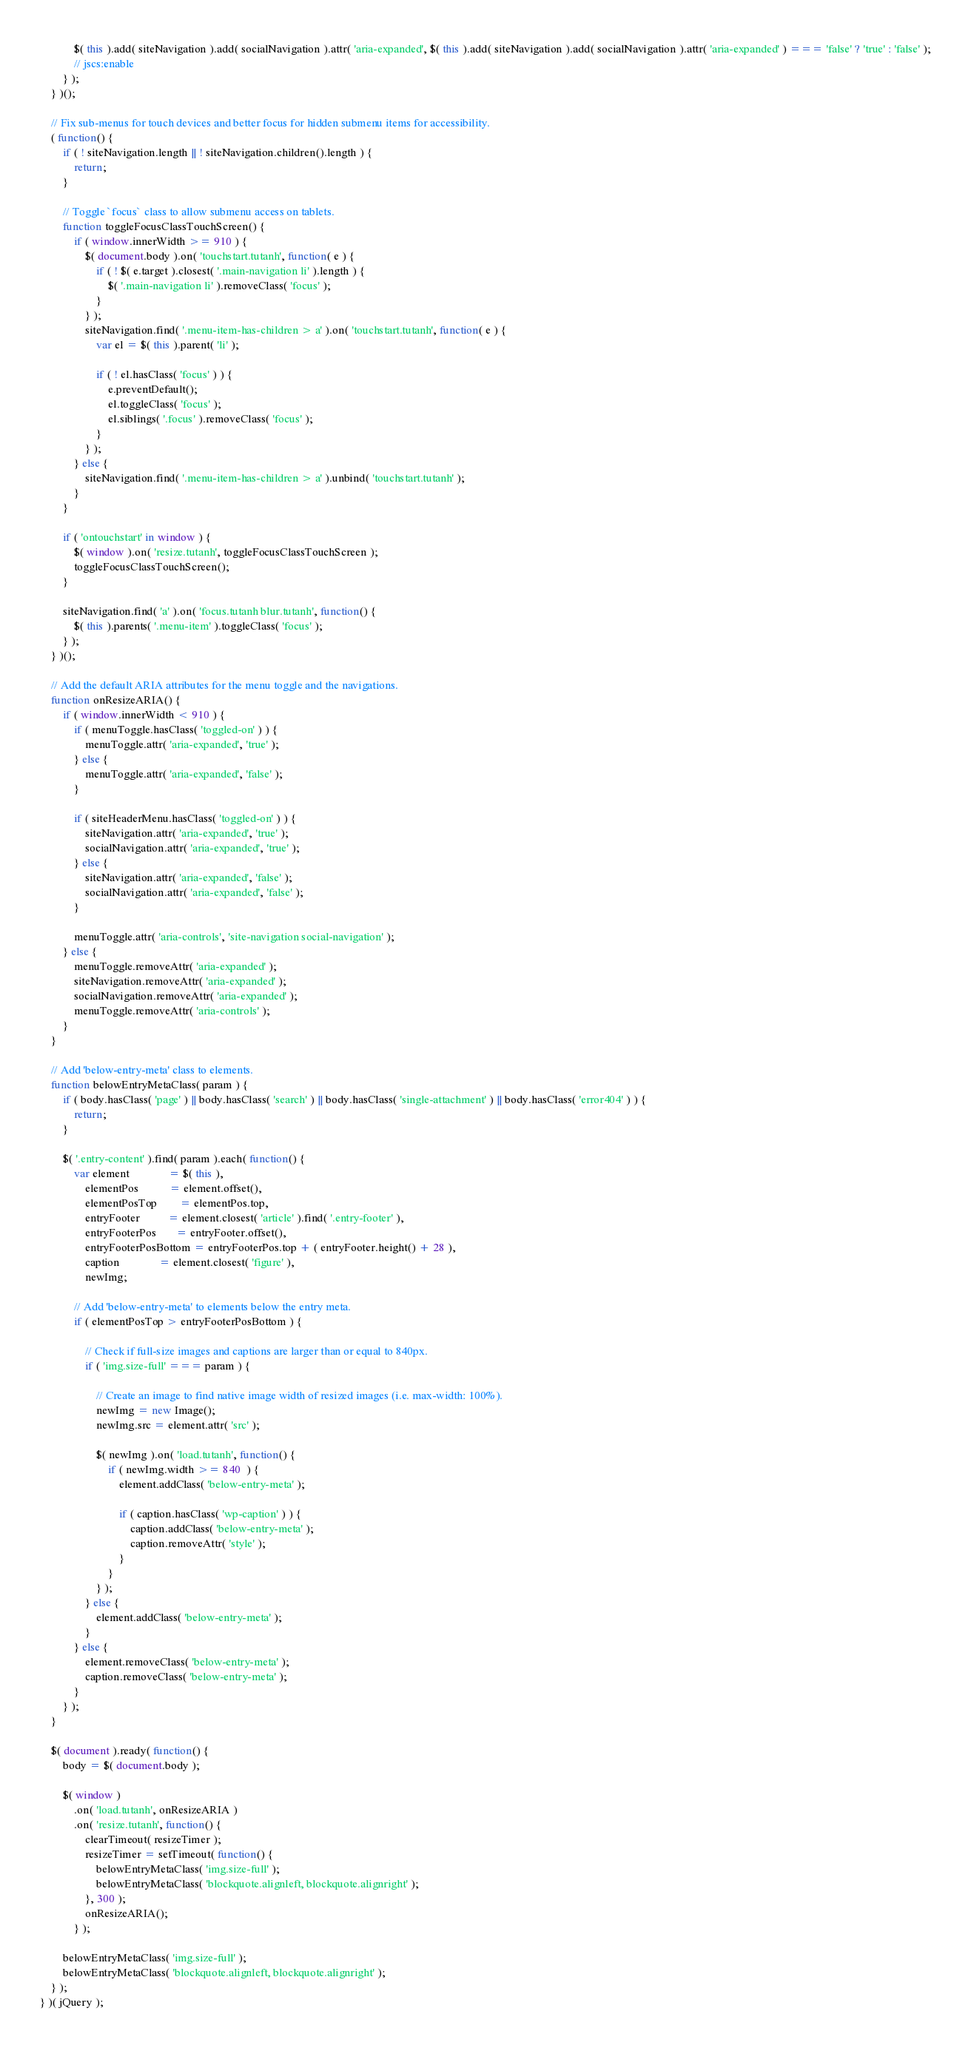Convert code to text. <code><loc_0><loc_0><loc_500><loc_500><_JavaScript_>			$( this ).add( siteNavigation ).add( socialNavigation ).attr( 'aria-expanded', $( this ).add( siteNavigation ).add( socialNavigation ).attr( 'aria-expanded' ) === 'false' ? 'true' : 'false' );
			// jscs:enable
		} );
	} )();

	// Fix sub-menus for touch devices and better focus for hidden submenu items for accessibility.
	( function() {
		if ( ! siteNavigation.length || ! siteNavigation.children().length ) {
			return;
		}

		// Toggle `focus` class to allow submenu access on tablets.
		function toggleFocusClassTouchScreen() {
			if ( window.innerWidth >= 910 ) {
				$( document.body ).on( 'touchstart.tutanh', function( e ) {
					if ( ! $( e.target ).closest( '.main-navigation li' ).length ) {
						$( '.main-navigation li' ).removeClass( 'focus' );
					}
				} );
				siteNavigation.find( '.menu-item-has-children > a' ).on( 'touchstart.tutanh', function( e ) {
					var el = $( this ).parent( 'li' );

					if ( ! el.hasClass( 'focus' ) ) {
						e.preventDefault();
						el.toggleClass( 'focus' );
						el.siblings( '.focus' ).removeClass( 'focus' );
					}
				} );
			} else {
				siteNavigation.find( '.menu-item-has-children > a' ).unbind( 'touchstart.tutanh' );
			}
		}

		if ( 'ontouchstart' in window ) {
			$( window ).on( 'resize.tutanh', toggleFocusClassTouchScreen );
			toggleFocusClassTouchScreen();
		}

		siteNavigation.find( 'a' ).on( 'focus.tutanh blur.tutanh', function() {
			$( this ).parents( '.menu-item' ).toggleClass( 'focus' );
		} );
	} )();

	// Add the default ARIA attributes for the menu toggle and the navigations.
	function onResizeARIA() {
		if ( window.innerWidth < 910 ) {
			if ( menuToggle.hasClass( 'toggled-on' ) ) {
				menuToggle.attr( 'aria-expanded', 'true' );
			} else {
				menuToggle.attr( 'aria-expanded', 'false' );
			}

			if ( siteHeaderMenu.hasClass( 'toggled-on' ) ) {
				siteNavigation.attr( 'aria-expanded', 'true' );
				socialNavigation.attr( 'aria-expanded', 'true' );
			} else {
				siteNavigation.attr( 'aria-expanded', 'false' );
				socialNavigation.attr( 'aria-expanded', 'false' );
			}

			menuToggle.attr( 'aria-controls', 'site-navigation social-navigation' );
		} else {
			menuToggle.removeAttr( 'aria-expanded' );
			siteNavigation.removeAttr( 'aria-expanded' );
			socialNavigation.removeAttr( 'aria-expanded' );
			menuToggle.removeAttr( 'aria-controls' );
		}
	}

	// Add 'below-entry-meta' class to elements.
	function belowEntryMetaClass( param ) {
		if ( body.hasClass( 'page' ) || body.hasClass( 'search' ) || body.hasClass( 'single-attachment' ) || body.hasClass( 'error404' ) ) {
			return;
		}

		$( '.entry-content' ).find( param ).each( function() {
			var element              = $( this ),
				elementPos           = element.offset(),
				elementPosTop        = elementPos.top,
				entryFooter          = element.closest( 'article' ).find( '.entry-footer' ),
				entryFooterPos       = entryFooter.offset(),
				entryFooterPosBottom = entryFooterPos.top + ( entryFooter.height() + 28 ),
				caption              = element.closest( 'figure' ),
				newImg;

			// Add 'below-entry-meta' to elements below the entry meta.
			if ( elementPosTop > entryFooterPosBottom ) {

				// Check if full-size images and captions are larger than or equal to 840px.
				if ( 'img.size-full' === param ) {

					// Create an image to find native image width of resized images (i.e. max-width: 100%).
					newImg = new Image();
					newImg.src = element.attr( 'src' );

					$( newImg ).on( 'load.tutanh', function() {
						if ( newImg.width >= 840  ) {
							element.addClass( 'below-entry-meta' );

							if ( caption.hasClass( 'wp-caption' ) ) {
								caption.addClass( 'below-entry-meta' );
								caption.removeAttr( 'style' );
							}
						}
					} );
				} else {
					element.addClass( 'below-entry-meta' );
				}
			} else {
				element.removeClass( 'below-entry-meta' );
				caption.removeClass( 'below-entry-meta' );
			}
		} );
	}

	$( document ).ready( function() {
		body = $( document.body );

		$( window )
			.on( 'load.tutanh', onResizeARIA )
			.on( 'resize.tutanh', function() {
				clearTimeout( resizeTimer );
				resizeTimer = setTimeout( function() {
					belowEntryMetaClass( 'img.size-full' );
					belowEntryMetaClass( 'blockquote.alignleft, blockquote.alignright' );
				}, 300 );
				onResizeARIA();
			} );

		belowEntryMetaClass( 'img.size-full' );
		belowEntryMetaClass( 'blockquote.alignleft, blockquote.alignright' );
	} );
} )( jQuery );
</code> 